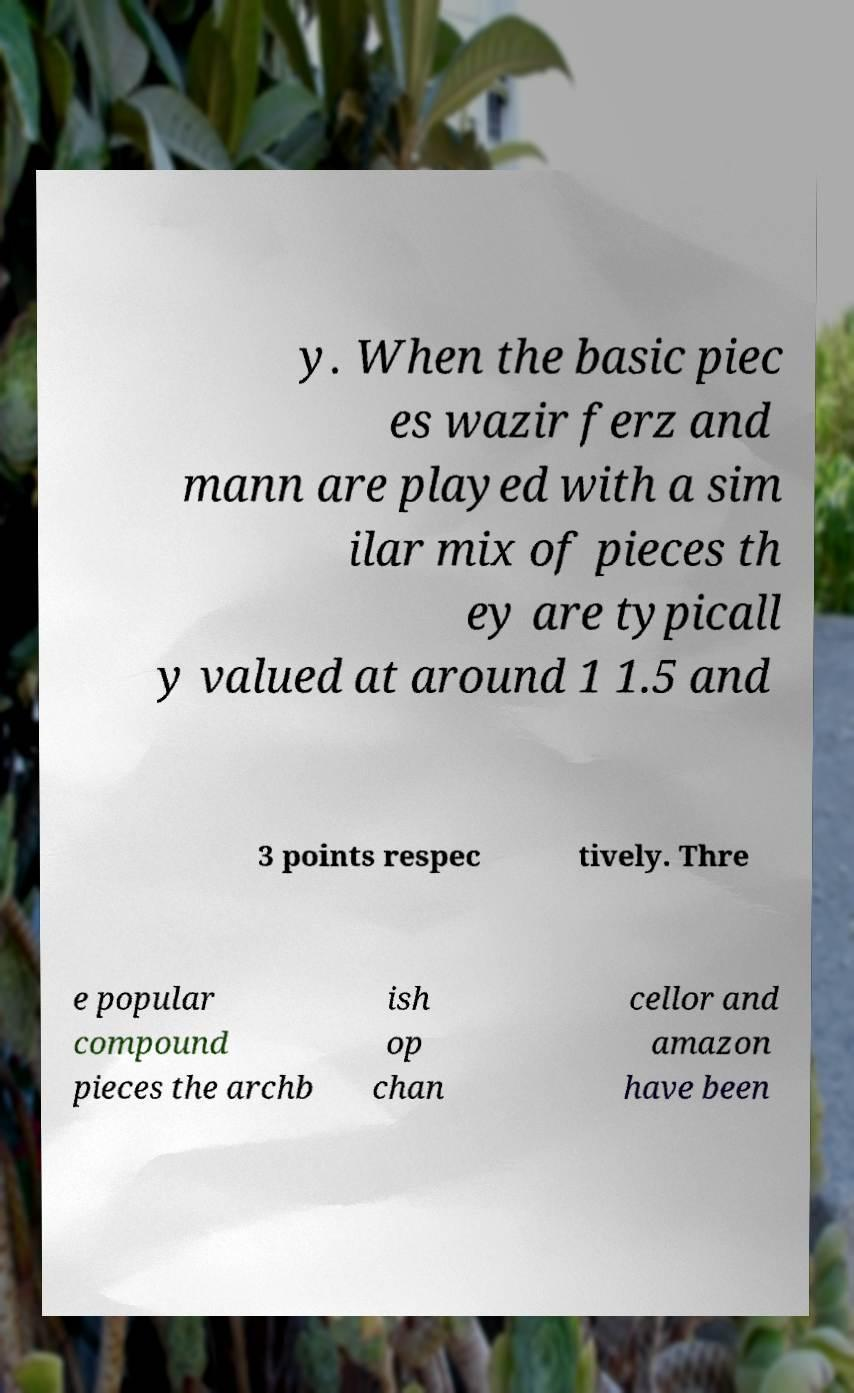For documentation purposes, I need the text within this image transcribed. Could you provide that? y. When the basic piec es wazir ferz and mann are played with a sim ilar mix of pieces th ey are typicall y valued at around 1 1.5 and 3 points respec tively. Thre e popular compound pieces the archb ish op chan cellor and amazon have been 